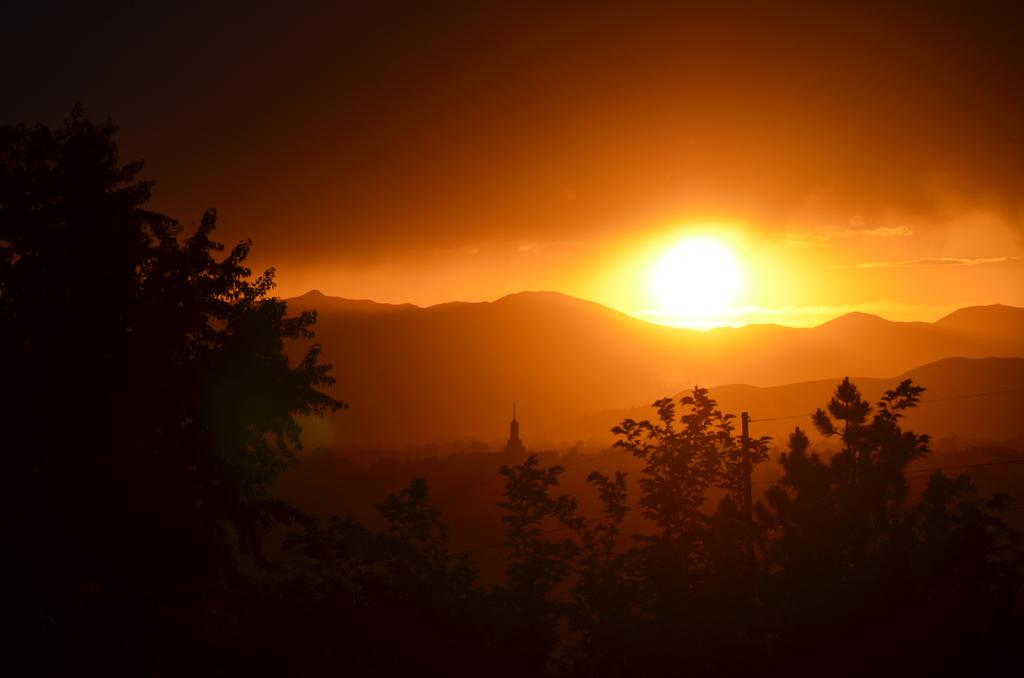What type of vegetation can be seen in the image? There are trees in the image. What type of geographical feature is present in the image? There are hills in the image. What is visible in the sky in the image? The sky is visible in the image. What celestial body can be seen in the sky in the image? The sun is visible in the image. What time is displayed on the clock in the image? There is no clock present in the image. What type of crib can be seen in the image? There is no crib present in the image. 